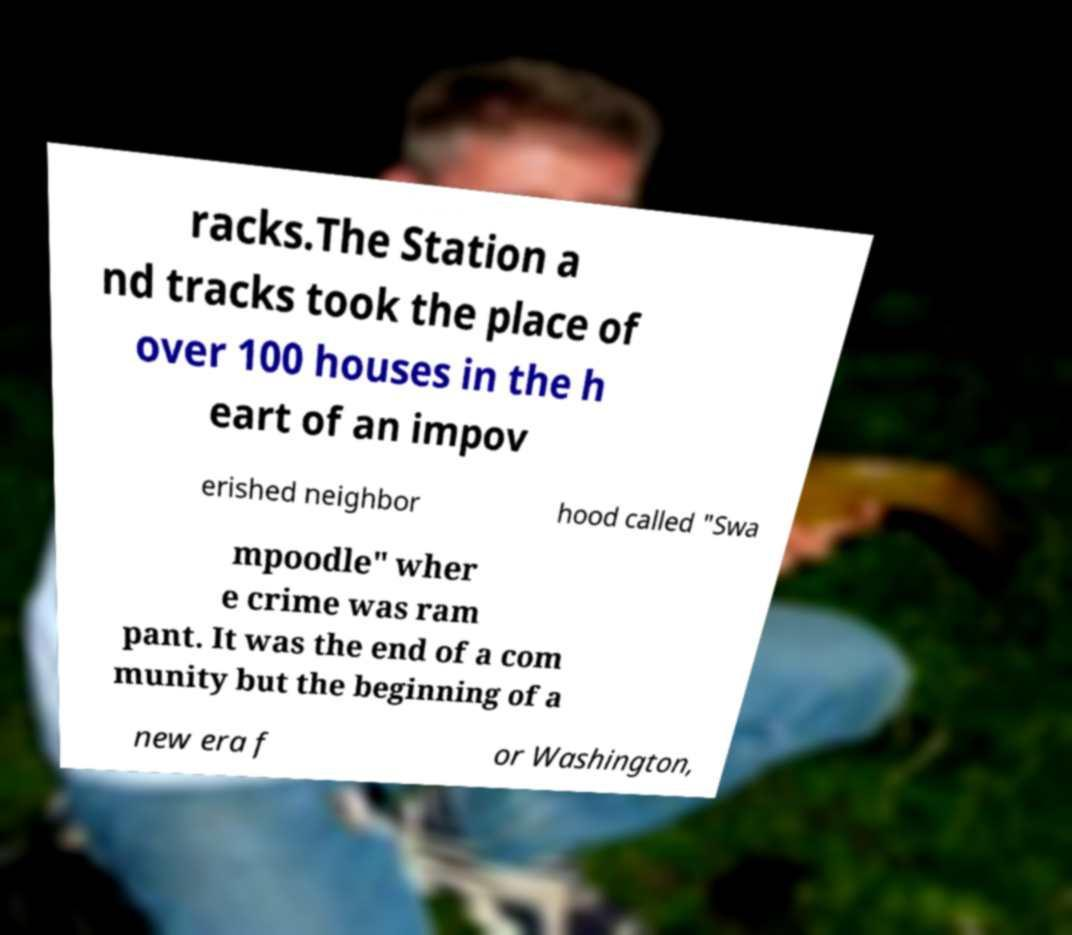What messages or text are displayed in this image? I need them in a readable, typed format. racks.The Station a nd tracks took the place of over 100 houses in the h eart of an impov erished neighbor hood called "Swa mpoodle" wher e crime was ram pant. It was the end of a com munity but the beginning of a new era f or Washington, 